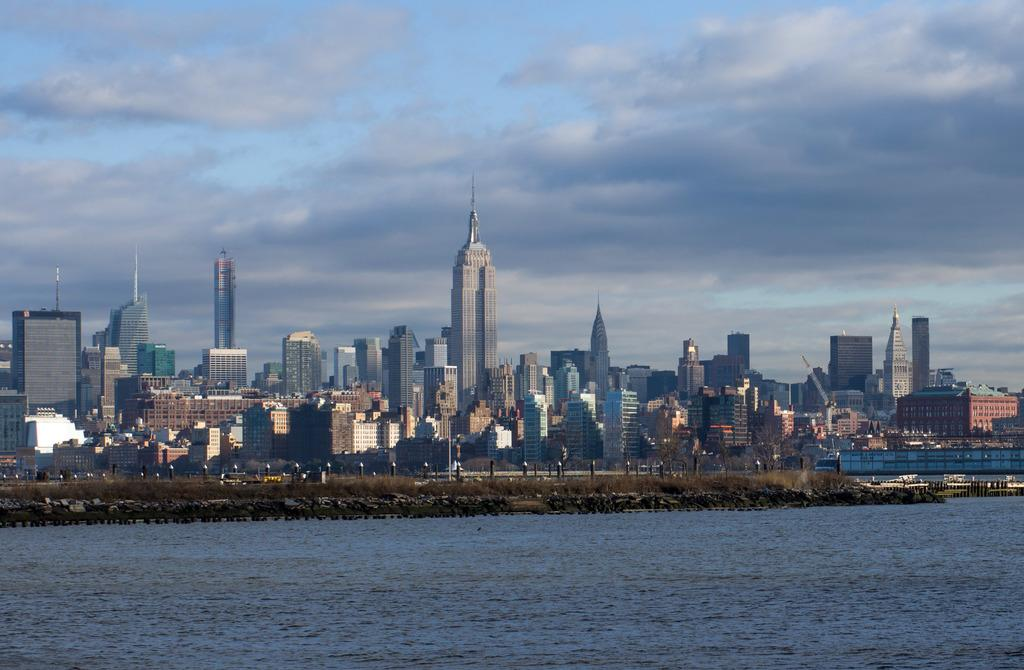What type of natural feature is at the bottom of the image? There is a river at the bottom of the image. What type of man-made structures are in the middle of the image? There are buildings in the middle of the image. What is visible at the top of the image? The sky is visible at the top of the image. How many cows are celebrating their birthday in the image? There are no cows or birthday celebrations present in the image. What type of debt is being discussed in the image? There is no discussion of debt in the image. 